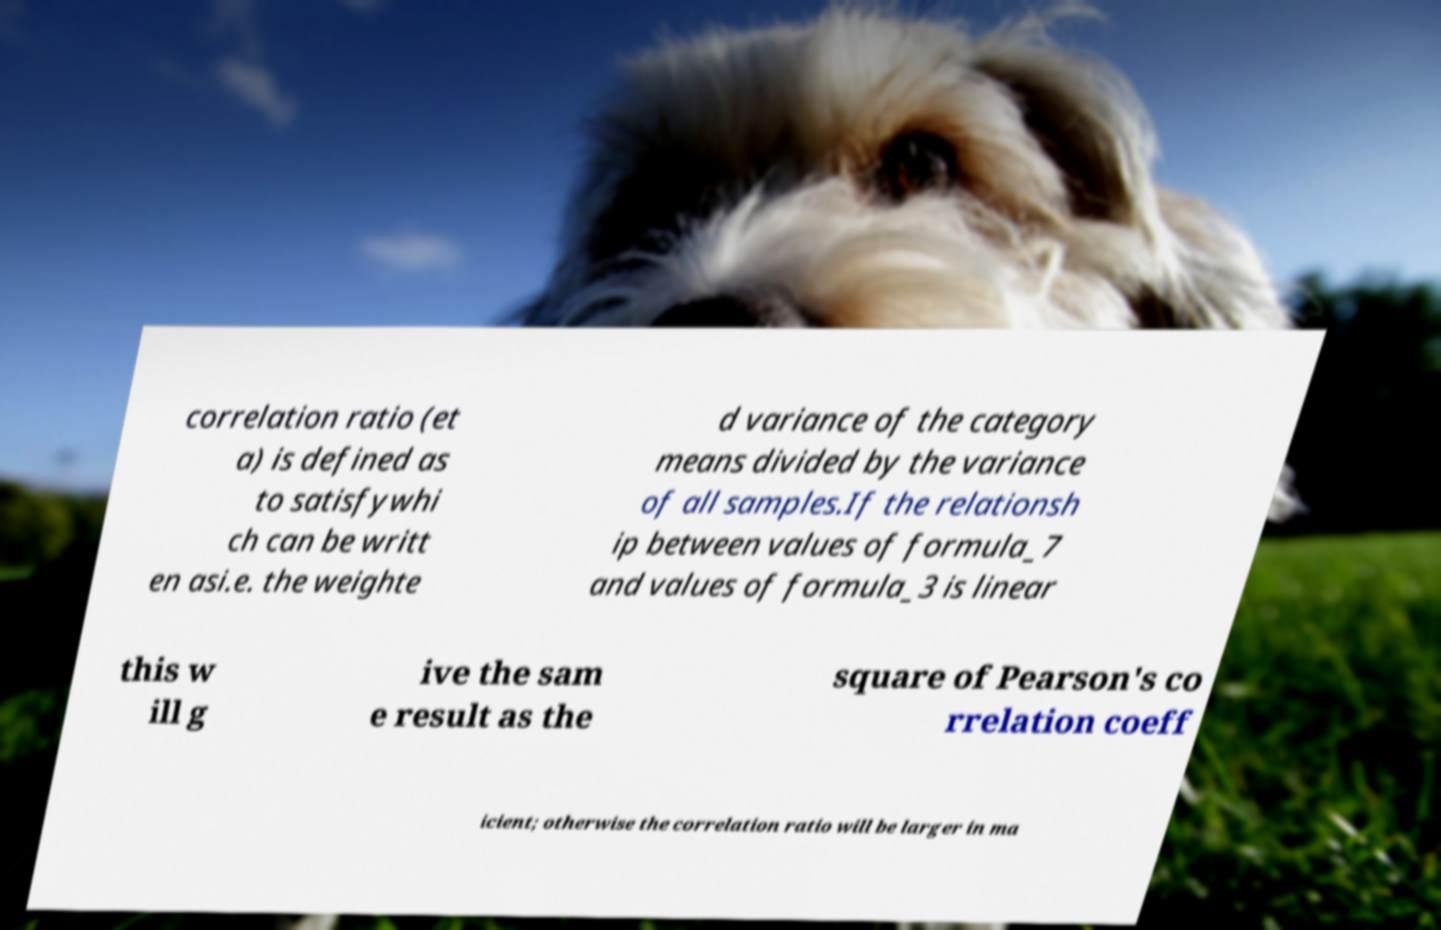For documentation purposes, I need the text within this image transcribed. Could you provide that? correlation ratio (et a) is defined as to satisfywhi ch can be writt en asi.e. the weighte d variance of the category means divided by the variance of all samples.If the relationsh ip between values of formula_7 and values of formula_3 is linear this w ill g ive the sam e result as the square of Pearson's co rrelation coeff icient; otherwise the correlation ratio will be larger in ma 